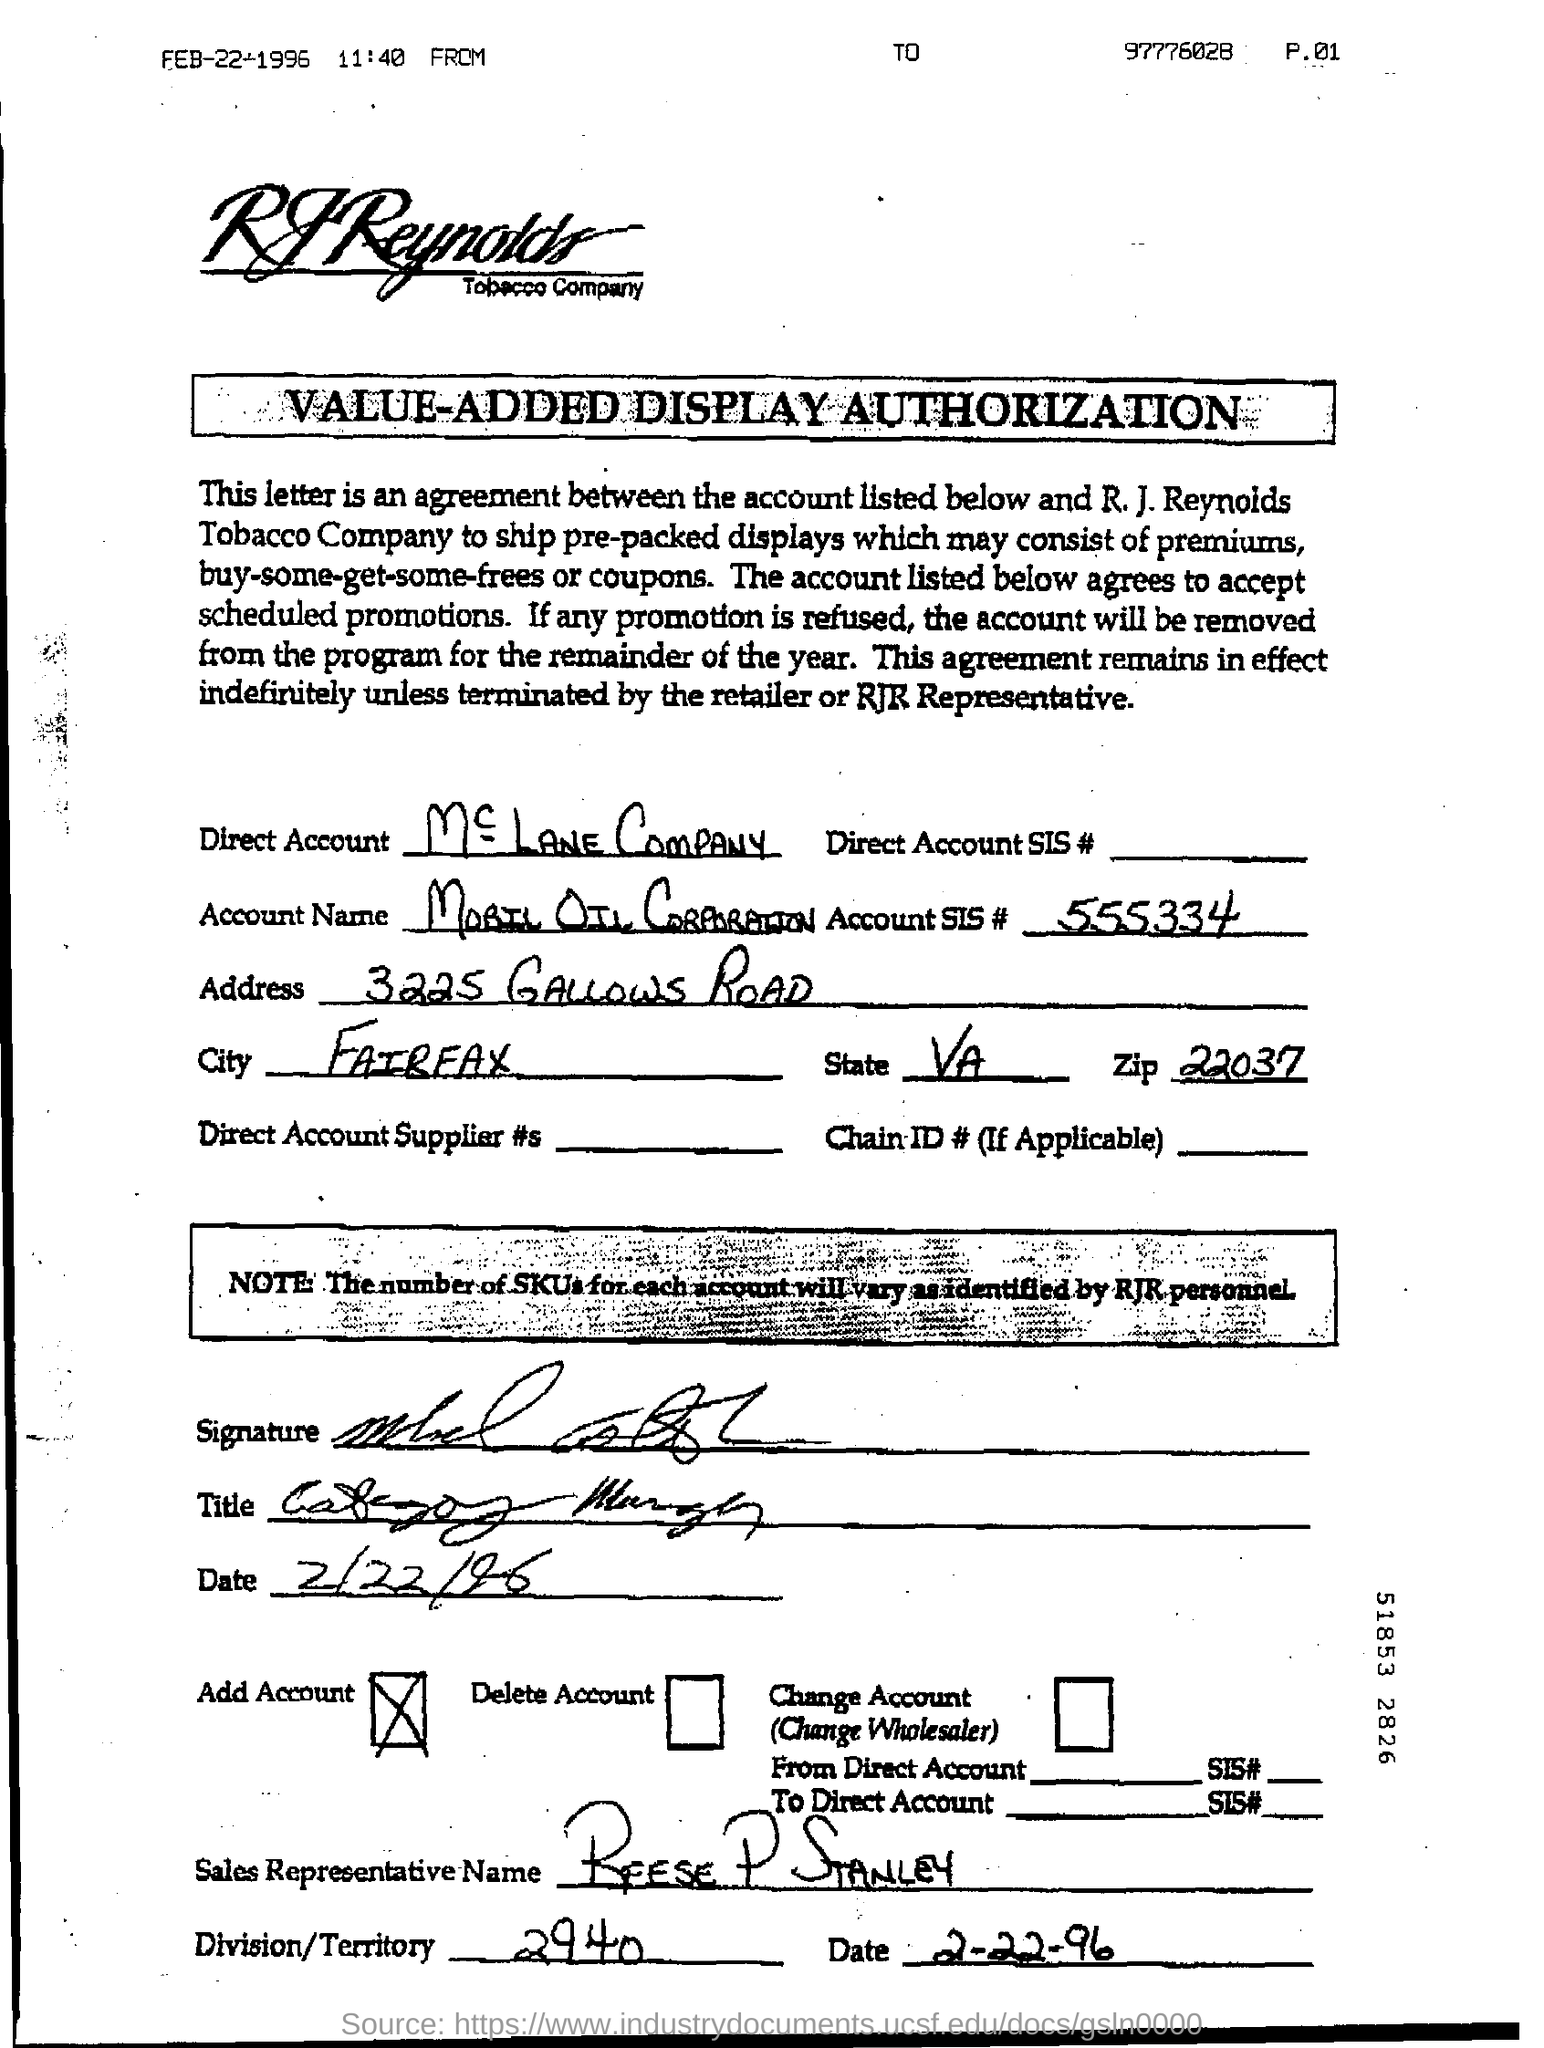What is the account SIS# mentioned in the document?
Give a very brief answer. 555334. What is the Account SIS #?
Your response must be concise. 555334. What is the City?
Your response must be concise. Fairfax. What is the Zip?
Make the answer very short. 22037. What is the Division/Territory?
Keep it short and to the point. 2940. What is the date on the document?
Ensure brevity in your answer.  2-22-96. 